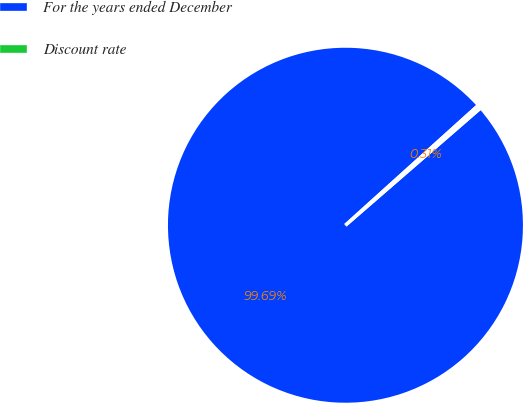<chart> <loc_0><loc_0><loc_500><loc_500><pie_chart><fcel>For the years ended December<fcel>Discount rate<nl><fcel>99.69%<fcel>0.31%<nl></chart> 